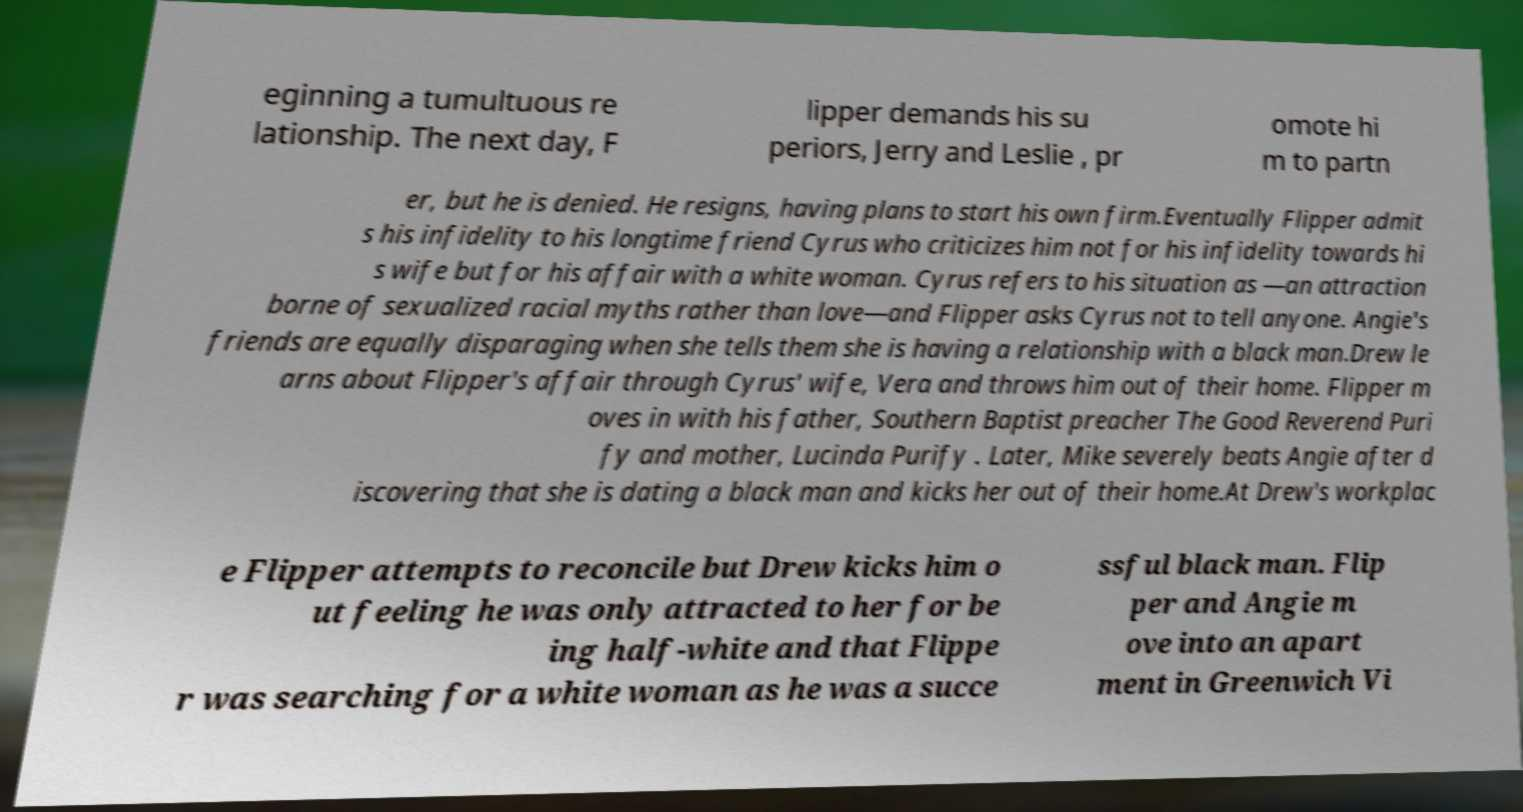Can you accurately transcribe the text from the provided image for me? eginning a tumultuous re lationship. The next day, F lipper demands his su periors, Jerry and Leslie , pr omote hi m to partn er, but he is denied. He resigns, having plans to start his own firm.Eventually Flipper admit s his infidelity to his longtime friend Cyrus who criticizes him not for his infidelity towards hi s wife but for his affair with a white woman. Cyrus refers to his situation as —an attraction borne of sexualized racial myths rather than love—and Flipper asks Cyrus not to tell anyone. Angie's friends are equally disparaging when she tells them she is having a relationship with a black man.Drew le arns about Flipper's affair through Cyrus' wife, Vera and throws him out of their home. Flipper m oves in with his father, Southern Baptist preacher The Good Reverend Puri fy and mother, Lucinda Purify . Later, Mike severely beats Angie after d iscovering that she is dating a black man and kicks her out of their home.At Drew's workplac e Flipper attempts to reconcile but Drew kicks him o ut feeling he was only attracted to her for be ing half-white and that Flippe r was searching for a white woman as he was a succe ssful black man. Flip per and Angie m ove into an apart ment in Greenwich Vi 